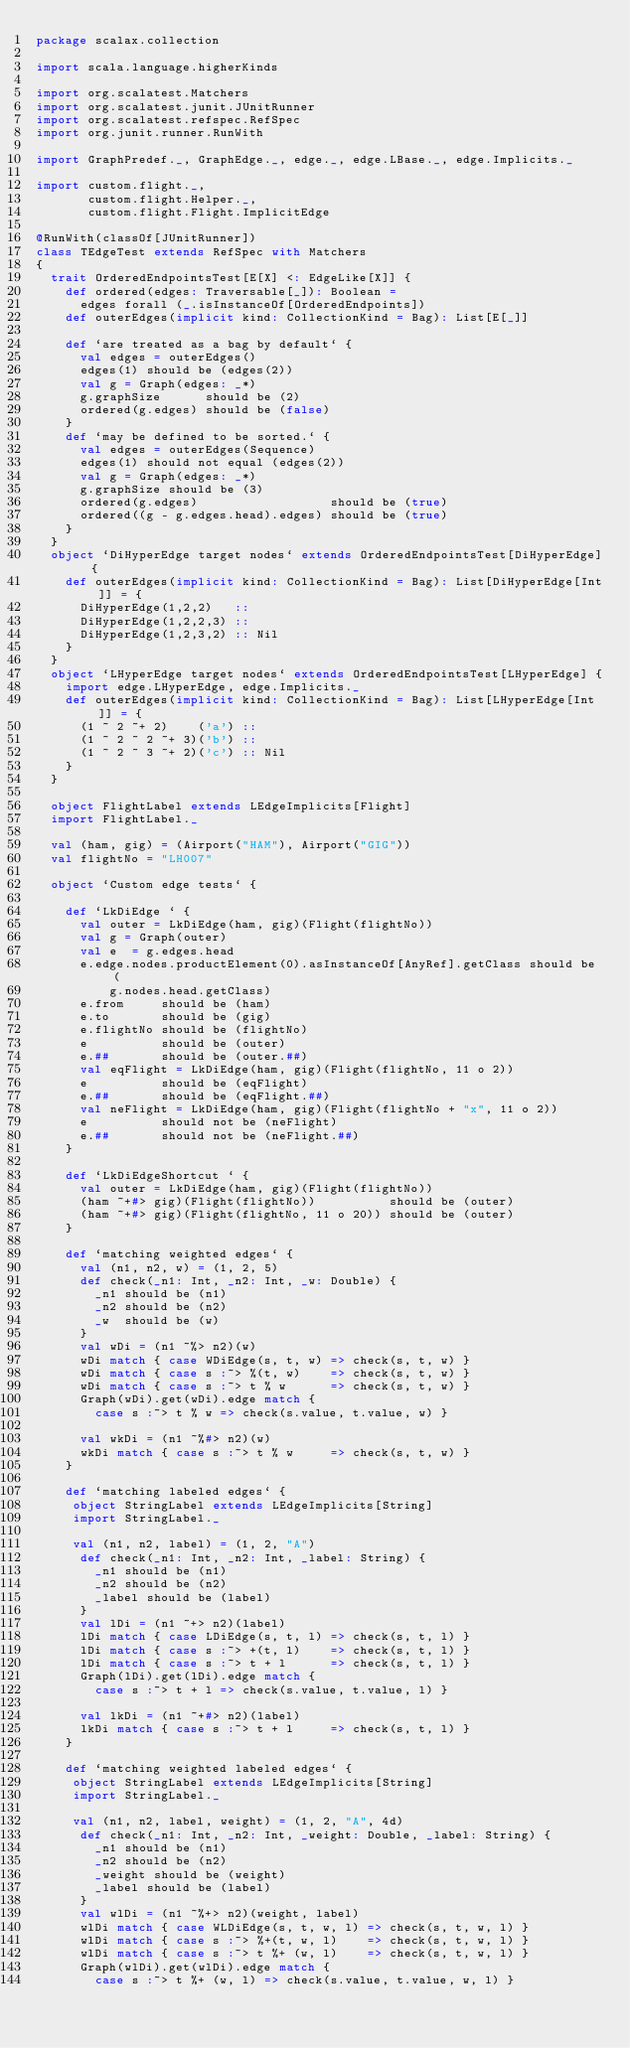Convert code to text. <code><loc_0><loc_0><loc_500><loc_500><_Scala_>package scalax.collection

import scala.language.higherKinds

import org.scalatest.Matchers
import org.scalatest.junit.JUnitRunner
import org.scalatest.refspec.RefSpec
import org.junit.runner.RunWith

import GraphPredef._, GraphEdge._, edge._, edge.LBase._, edge.Implicits._

import custom.flight._,
       custom.flight.Helper._,
       custom.flight.Flight.ImplicitEdge

@RunWith(classOf[JUnitRunner])
class TEdgeTest extends RefSpec with Matchers
{
  trait OrderedEndpointsTest[E[X] <: EdgeLike[X]] {
    def ordered(edges: Traversable[_]): Boolean =
      edges forall (_.isInstanceOf[OrderedEndpoints])
    def outerEdges(implicit kind: CollectionKind = Bag): List[E[_]]
  
    def `are treated as a bag by default` {
      val edges = outerEdges()
      edges(1) should be (edges(2))
      val g = Graph(edges: _*)
      g.graphSize      should be (2)
      ordered(g.edges) should be (false)
    }
    def `may be defined to be sorted.` {
      val edges = outerEdges(Sequence)
      edges(1) should not equal (edges(2))
      val g = Graph(edges: _*)
      g.graphSize should be (3)
      ordered(g.edges)                  should be (true)
      ordered((g - g.edges.head).edges) should be (true)
    } 
  }
  object `DiHyperEdge target nodes` extends OrderedEndpointsTest[DiHyperEdge] {
    def outerEdges(implicit kind: CollectionKind = Bag): List[DiHyperEdge[Int]] = {
      DiHyperEdge(1,2,2)   ::
      DiHyperEdge(1,2,2,3) ::
      DiHyperEdge(1,2,3,2) :: Nil
    }
  }
  object `LHyperEdge target nodes` extends OrderedEndpointsTest[LHyperEdge] {
    import edge.LHyperEdge, edge.Implicits._
    def outerEdges(implicit kind: CollectionKind = Bag): List[LHyperEdge[Int]] = {
      (1 ~ 2 ~+ 2)    ('a') ::
      (1 ~ 2 ~ 2 ~+ 3)('b') ::
      (1 ~ 2 ~ 3 ~+ 2)('c') :: Nil
    }
  }

  object FlightLabel extends LEdgeImplicits[Flight]
  import FlightLabel._

  val (ham, gig) = (Airport("HAM"), Airport("GIG"))
  val flightNo = "LH007"

  object `Custom edge tests` {
    
    def `LkDiEdge ` {
      val outer = LkDiEdge(ham, gig)(Flight(flightNo))
      val g = Graph(outer)
      val e  = g.edges.head
      e.edge.nodes.productElement(0).asInstanceOf[AnyRef].getClass should be (
          g.nodes.head.getClass)
      e.from     should be (ham)
      e.to       should be (gig)
      e.flightNo should be (flightNo)
      e          should be (outer)
      e.##       should be (outer.##)
      val eqFlight = LkDiEdge(ham, gig)(Flight(flightNo, 11 o 2))
      e          should be (eqFlight)
      e.##       should be (eqFlight.##)
      val neFlight = LkDiEdge(ham, gig)(Flight(flightNo + "x", 11 o 2))
      e          should not be (neFlight)
      e.##       should not be (neFlight.##)
    }
    
    def `LkDiEdgeShortcut ` {
      val outer = LkDiEdge(ham, gig)(Flight(flightNo))
      (ham ~+#> gig)(Flight(flightNo))          should be (outer)
      (ham ~+#> gig)(Flight(flightNo, 11 o 20)) should be (outer)
    }
    
    def `matching weighted edges` {
      val (n1, n2, w) = (1, 2, 5)
      def check(_n1: Int, _n2: Int, _w: Double) {
        _n1 should be (n1)
        _n2 should be (n2)
        _w  should be (w)
      }
      val wDi = (n1 ~%> n2)(w)
      wDi match { case WDiEdge(s, t, w) => check(s, t, w) }
      wDi match { case s :~> %(t, w)    => check(s, t, w) }
      wDi match { case s :~> t % w      => check(s, t, w) }
      Graph(wDi).get(wDi).edge match {
        case s :~> t % w => check(s.value, t.value, w) }
      
      val wkDi = (n1 ~%#> n2)(w)
      wkDi match { case s :~> t % w     => check(s, t, w) }
    }
    
    def `matching labeled edges` {
     object StringLabel extends LEdgeImplicits[String]
     import StringLabel._
  
     val (n1, n2, label) = (1, 2, "A")
      def check(_n1: Int, _n2: Int, _label: String) {
        _n1 should be (n1)
        _n2 should be (n2)
        _label should be (label)
      }
      val lDi = (n1 ~+> n2)(label)
      lDi match { case LDiEdge(s, t, l) => check(s, t, l) }
      lDi match { case s :~> +(t, l)    => check(s, t, l) }
      lDi match { case s :~> t + l      => check(s, t, l) }
      Graph(lDi).get(lDi).edge match {
        case s :~> t + l => check(s.value, t.value, l) }
  
      val lkDi = (n1 ~+#> n2)(label)
      lkDi match { case s :~> t + l     => check(s, t, l) }
    }
    
    def `matching weighted labeled edges` {
     object StringLabel extends LEdgeImplicits[String]
     import StringLabel._
  
     val (n1, n2, label, weight) = (1, 2, "A", 4d)
      def check(_n1: Int, _n2: Int, _weight: Double, _label: String) {
        _n1 should be (n1)
        _n2 should be (n2)
        _weight should be (weight)
        _label should be (label)
      }
      val wlDi = (n1 ~%+> n2)(weight, label)
      wlDi match { case WLDiEdge(s, t, w, l) => check(s, t, w, l) }
      wlDi match { case s :~> %+(t, w, l)    => check(s, t, w, l) }
      wlDi match { case s :~> t %+ (w, l)    => check(s, t, w, l) }
      Graph(wlDi).get(wlDi).edge match {
        case s :~> t %+ (w, l) => check(s.value, t.value, w, l) }
  </code> 